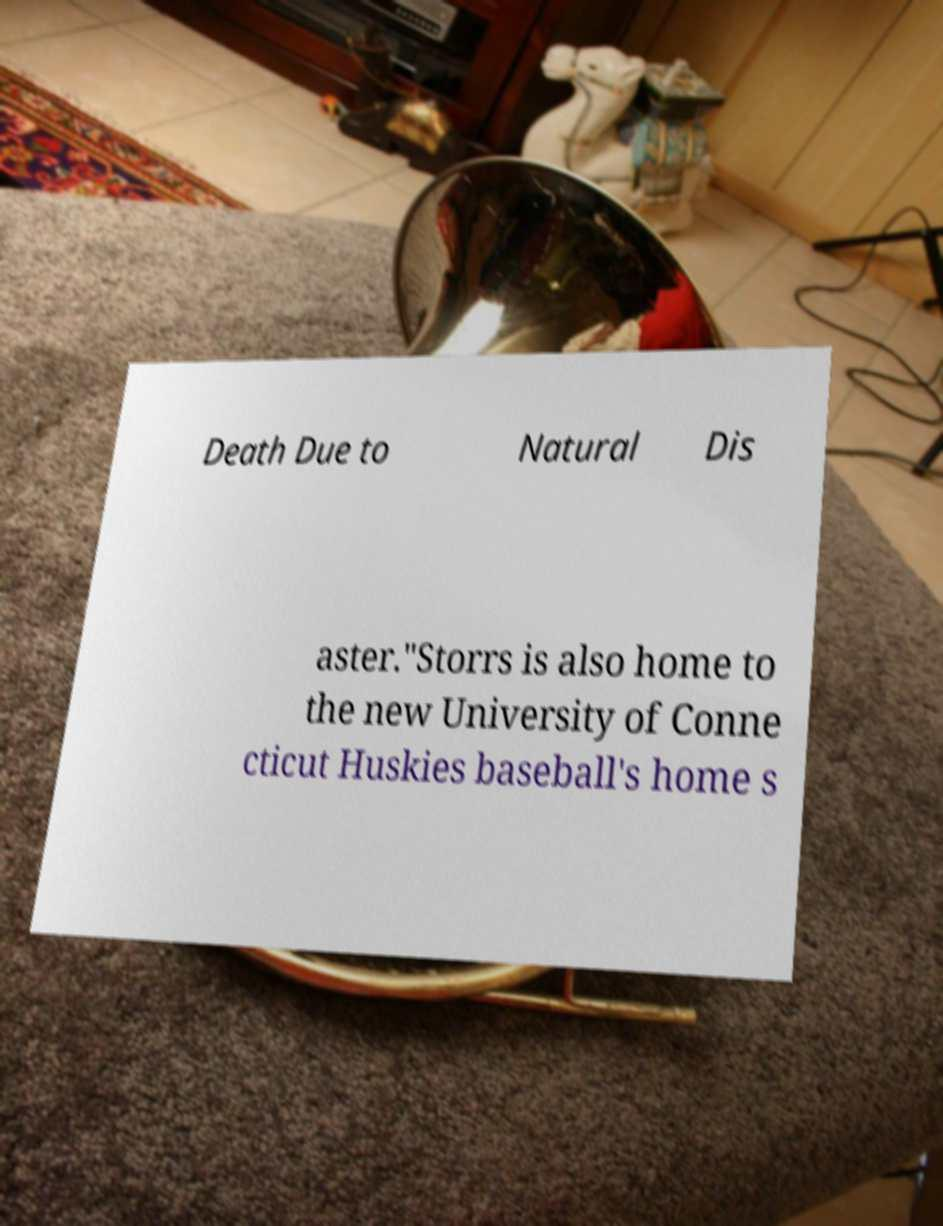Could you extract and type out the text from this image? Death Due to Natural Dis aster."Storrs is also home to the new University of Conne cticut Huskies baseball's home s 